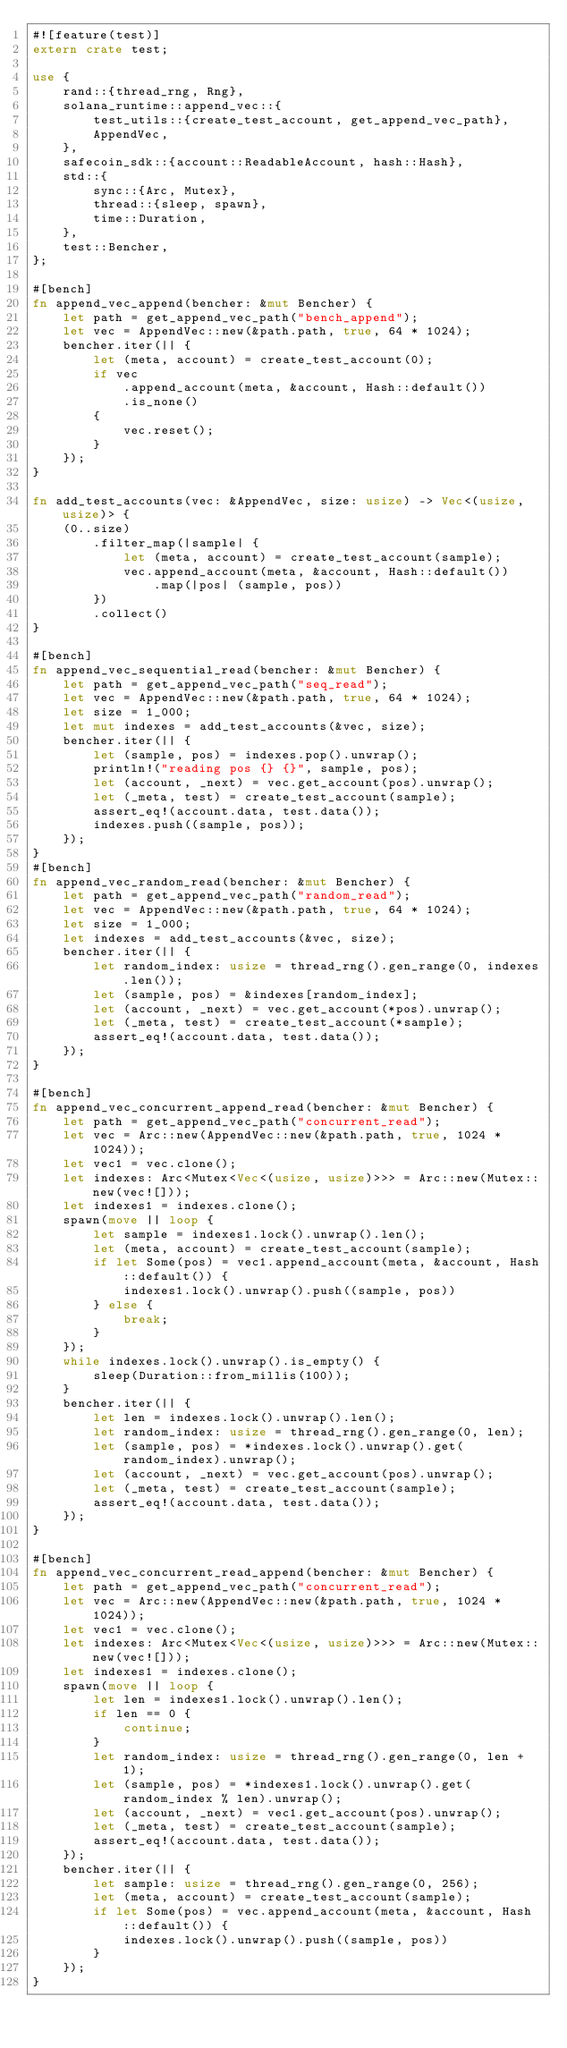Convert code to text. <code><loc_0><loc_0><loc_500><loc_500><_Rust_>#![feature(test)]
extern crate test;

use {
    rand::{thread_rng, Rng},
    solana_runtime::append_vec::{
        test_utils::{create_test_account, get_append_vec_path},
        AppendVec,
    },
    safecoin_sdk::{account::ReadableAccount, hash::Hash},
    std::{
        sync::{Arc, Mutex},
        thread::{sleep, spawn},
        time::Duration,
    },
    test::Bencher,
};

#[bench]
fn append_vec_append(bencher: &mut Bencher) {
    let path = get_append_vec_path("bench_append");
    let vec = AppendVec::new(&path.path, true, 64 * 1024);
    bencher.iter(|| {
        let (meta, account) = create_test_account(0);
        if vec
            .append_account(meta, &account, Hash::default())
            .is_none()
        {
            vec.reset();
        }
    });
}

fn add_test_accounts(vec: &AppendVec, size: usize) -> Vec<(usize, usize)> {
    (0..size)
        .filter_map(|sample| {
            let (meta, account) = create_test_account(sample);
            vec.append_account(meta, &account, Hash::default())
                .map(|pos| (sample, pos))
        })
        .collect()
}

#[bench]
fn append_vec_sequential_read(bencher: &mut Bencher) {
    let path = get_append_vec_path("seq_read");
    let vec = AppendVec::new(&path.path, true, 64 * 1024);
    let size = 1_000;
    let mut indexes = add_test_accounts(&vec, size);
    bencher.iter(|| {
        let (sample, pos) = indexes.pop().unwrap();
        println!("reading pos {} {}", sample, pos);
        let (account, _next) = vec.get_account(pos).unwrap();
        let (_meta, test) = create_test_account(sample);
        assert_eq!(account.data, test.data());
        indexes.push((sample, pos));
    });
}
#[bench]
fn append_vec_random_read(bencher: &mut Bencher) {
    let path = get_append_vec_path("random_read");
    let vec = AppendVec::new(&path.path, true, 64 * 1024);
    let size = 1_000;
    let indexes = add_test_accounts(&vec, size);
    bencher.iter(|| {
        let random_index: usize = thread_rng().gen_range(0, indexes.len());
        let (sample, pos) = &indexes[random_index];
        let (account, _next) = vec.get_account(*pos).unwrap();
        let (_meta, test) = create_test_account(*sample);
        assert_eq!(account.data, test.data());
    });
}

#[bench]
fn append_vec_concurrent_append_read(bencher: &mut Bencher) {
    let path = get_append_vec_path("concurrent_read");
    let vec = Arc::new(AppendVec::new(&path.path, true, 1024 * 1024));
    let vec1 = vec.clone();
    let indexes: Arc<Mutex<Vec<(usize, usize)>>> = Arc::new(Mutex::new(vec![]));
    let indexes1 = indexes.clone();
    spawn(move || loop {
        let sample = indexes1.lock().unwrap().len();
        let (meta, account) = create_test_account(sample);
        if let Some(pos) = vec1.append_account(meta, &account, Hash::default()) {
            indexes1.lock().unwrap().push((sample, pos))
        } else {
            break;
        }
    });
    while indexes.lock().unwrap().is_empty() {
        sleep(Duration::from_millis(100));
    }
    bencher.iter(|| {
        let len = indexes.lock().unwrap().len();
        let random_index: usize = thread_rng().gen_range(0, len);
        let (sample, pos) = *indexes.lock().unwrap().get(random_index).unwrap();
        let (account, _next) = vec.get_account(pos).unwrap();
        let (_meta, test) = create_test_account(sample);
        assert_eq!(account.data, test.data());
    });
}

#[bench]
fn append_vec_concurrent_read_append(bencher: &mut Bencher) {
    let path = get_append_vec_path("concurrent_read");
    let vec = Arc::new(AppendVec::new(&path.path, true, 1024 * 1024));
    let vec1 = vec.clone();
    let indexes: Arc<Mutex<Vec<(usize, usize)>>> = Arc::new(Mutex::new(vec![]));
    let indexes1 = indexes.clone();
    spawn(move || loop {
        let len = indexes1.lock().unwrap().len();
        if len == 0 {
            continue;
        }
        let random_index: usize = thread_rng().gen_range(0, len + 1);
        let (sample, pos) = *indexes1.lock().unwrap().get(random_index % len).unwrap();
        let (account, _next) = vec1.get_account(pos).unwrap();
        let (_meta, test) = create_test_account(sample);
        assert_eq!(account.data, test.data());
    });
    bencher.iter(|| {
        let sample: usize = thread_rng().gen_range(0, 256);
        let (meta, account) = create_test_account(sample);
        if let Some(pos) = vec.append_account(meta, &account, Hash::default()) {
            indexes.lock().unwrap().push((sample, pos))
        }
    });
}
</code> 